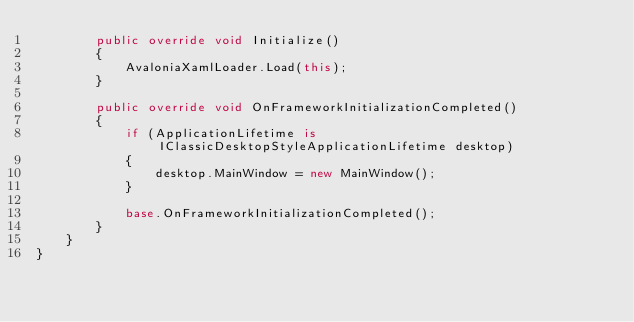<code> <loc_0><loc_0><loc_500><loc_500><_C#_>        public override void Initialize()
        {
            AvaloniaXamlLoader.Load(this);
        }

        public override void OnFrameworkInitializationCompleted()
        {
            if (ApplicationLifetime is IClassicDesktopStyleApplicationLifetime desktop)
            {
                desktop.MainWindow = new MainWindow();
            }

            base.OnFrameworkInitializationCompleted();
        }
    }
}
</code> 